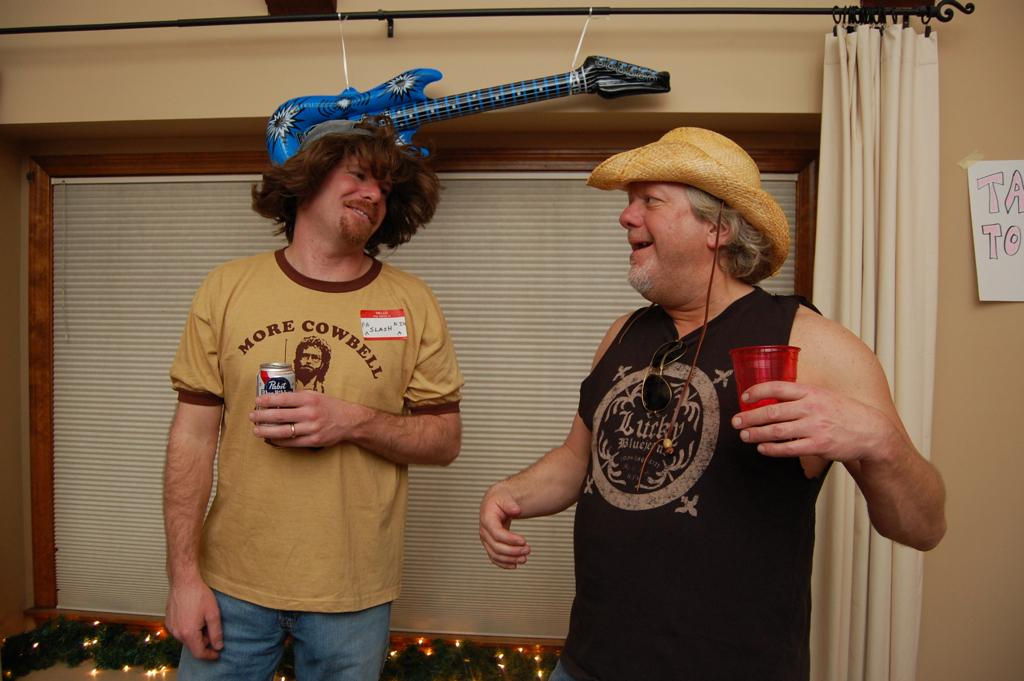How many people are in the image? There are two men in the image. What are the men doing in the image? Both men are standing and holding things. What can be observed about the men's expressions? The men have smiles on their faces. What can be seen in the background of the image? There is a plastic guitar and a curtain in the background of the image. What type of tools does the carpenter use in the image? There is no carpenter present in the image, and therefore no tools can be observed. What is the title of the song being played on the plastic guitar in the image? There is no indication of a song being played on the plastic guitar in the image, so it cannot be determined. 